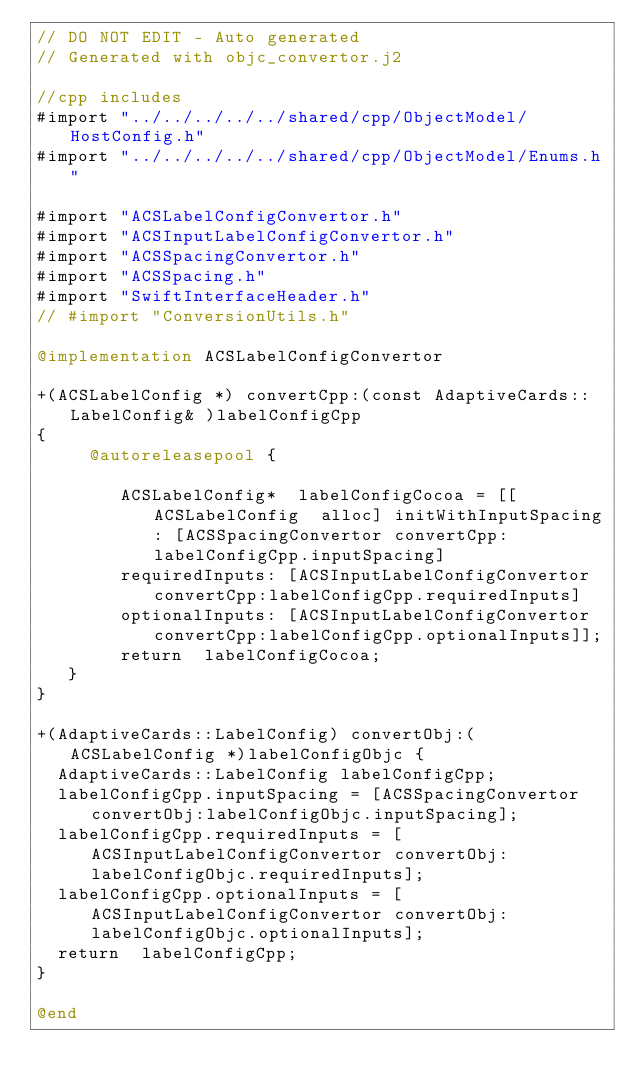Convert code to text. <code><loc_0><loc_0><loc_500><loc_500><_ObjectiveC_>// DO NOT EDIT - Auto generated
// Generated with objc_convertor.j2

//cpp includes 
#import "../../../../../shared/cpp/ObjectModel/HostConfig.h"
#import "../../../../../shared/cpp/ObjectModel/Enums.h"

#import "ACSLabelConfigConvertor.h"
#import "ACSInputLabelConfigConvertor.h"
#import "ACSSpacingConvertor.h"
#import "ACSSpacing.h"
#import "SwiftInterfaceHeader.h"
// #import "ConversionUtils.h"

@implementation ACSLabelConfigConvertor 

+(ACSLabelConfig *) convertCpp:(const AdaptiveCards::LabelConfig& )labelConfigCpp
{ 
     @autoreleasepool { 
 
        ACSLabelConfig*  labelConfigCocoa = [[ ACSLabelConfig  alloc] initWithInputSpacing: [ACSSpacingConvertor convertCpp:labelConfigCpp.inputSpacing] 
        requiredInputs: [ACSInputLabelConfigConvertor convertCpp:labelConfigCpp.requiredInputs]
        optionalInputs: [ACSInputLabelConfigConvertor convertCpp:labelConfigCpp.optionalInputs]];
        return  labelConfigCocoa;
   }
}

+(AdaptiveCards::LabelConfig) convertObj:(ACSLabelConfig *)labelConfigObjc {
  AdaptiveCards::LabelConfig labelConfigCpp;
  labelConfigCpp.inputSpacing = [ACSSpacingConvertor convertObj:labelConfigObjc.inputSpacing];
  labelConfigCpp.requiredInputs = [ACSInputLabelConfigConvertor convertObj:labelConfigObjc.requiredInputs];
  labelConfigCpp.optionalInputs = [ACSInputLabelConfigConvertor convertObj:labelConfigObjc.optionalInputs];
  return  labelConfigCpp;
}

@end 
</code> 